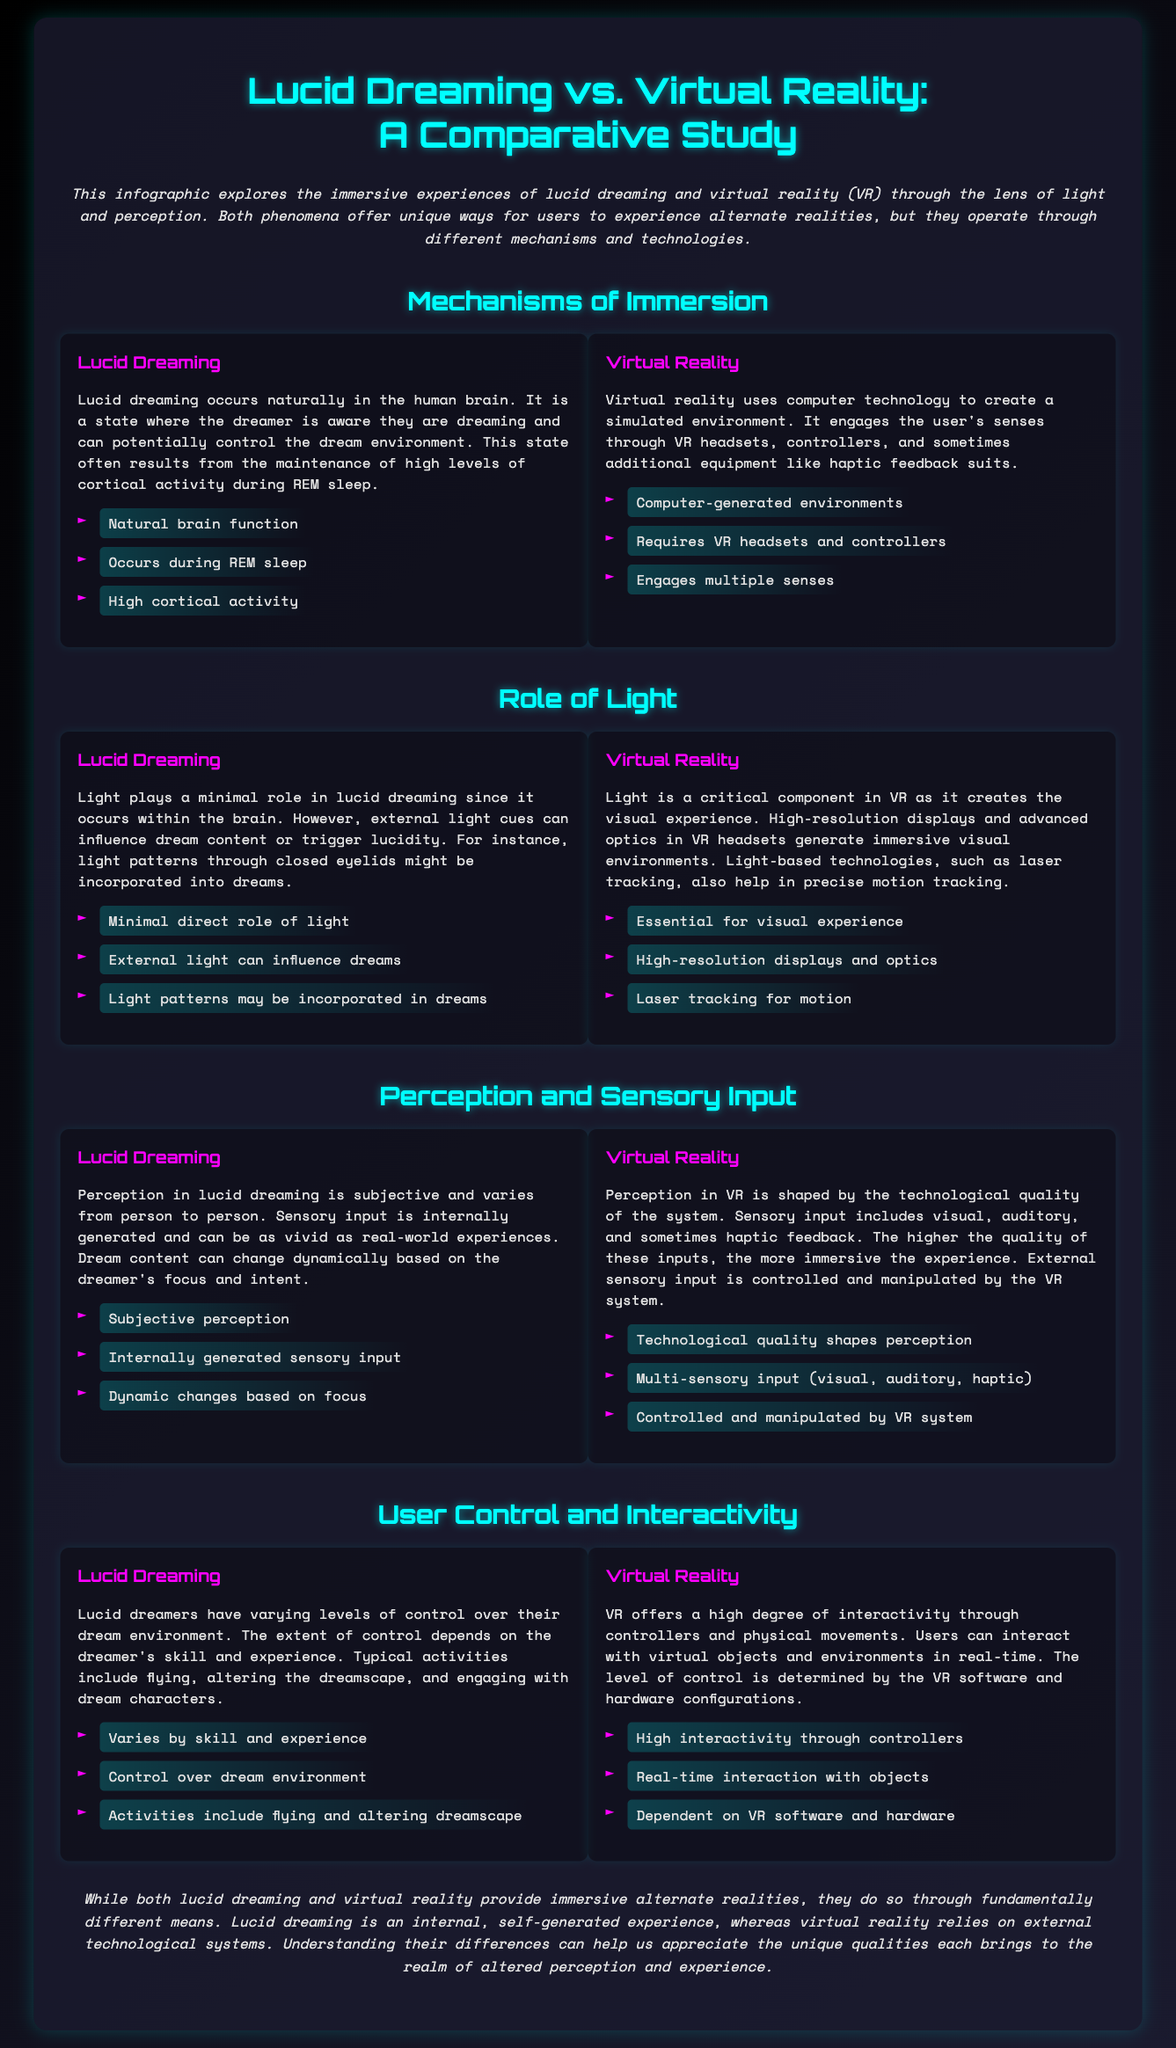What is the main focus of the infographic? The infographic explores the immersive experiences of lucid dreaming and virtual reality through the lens of light and perception.
Answer: Light and perception What is the primary mechanism for lucid dreaming? The primary mechanism for lucid dreaming is that it occurs naturally in the human brain during REM sleep with high cortical activity.
Answer: Natural brain function How does virtual reality primarily engage users? Virtual reality engages users through VR headsets and controllers to create a simulated environment.
Answer: VR headsets and controllers What role does light play in lucid dreaming? Light plays a minimal role in lucid dreaming, influencing dream content through external light cues.
Answer: Minimal direct role of light What determines the level of interactivity in virtual reality? The level of interactivity in virtual reality is dependent on the VR software and hardware configurations.
Answer: VR software and hardware How does perception in lucid dreaming compare to virtual reality? Perception in lucid dreaming is subjective and internally generated, while perception in VR is shaped by technological quality and external sensory input.
Answer: Subjective vs. technological quality What is one function of light in virtual reality? Light is essential for creating the visual experience, with high-resolution displays and advanced optics.
Answer: Essential for visual experience What can influence dream content in lucid dreaming? External light can influence dream content or trigger lucidity in lucid dreaming.
Answer: External light What type of experiences do lucid dreamers typically have? Lucid dreamers typically have control over their dream environment and can fly or alter the dreamscape.
Answer: Flying and altering dreamscape 